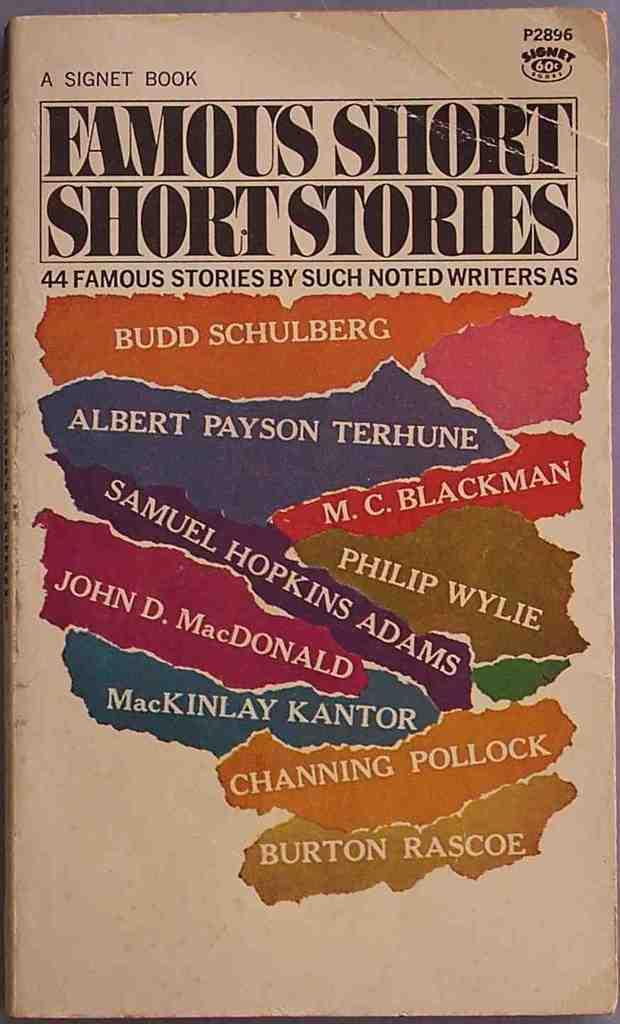<image>
Describe the image concisely. A book of Famous Short Short Stories by many noted authors. 